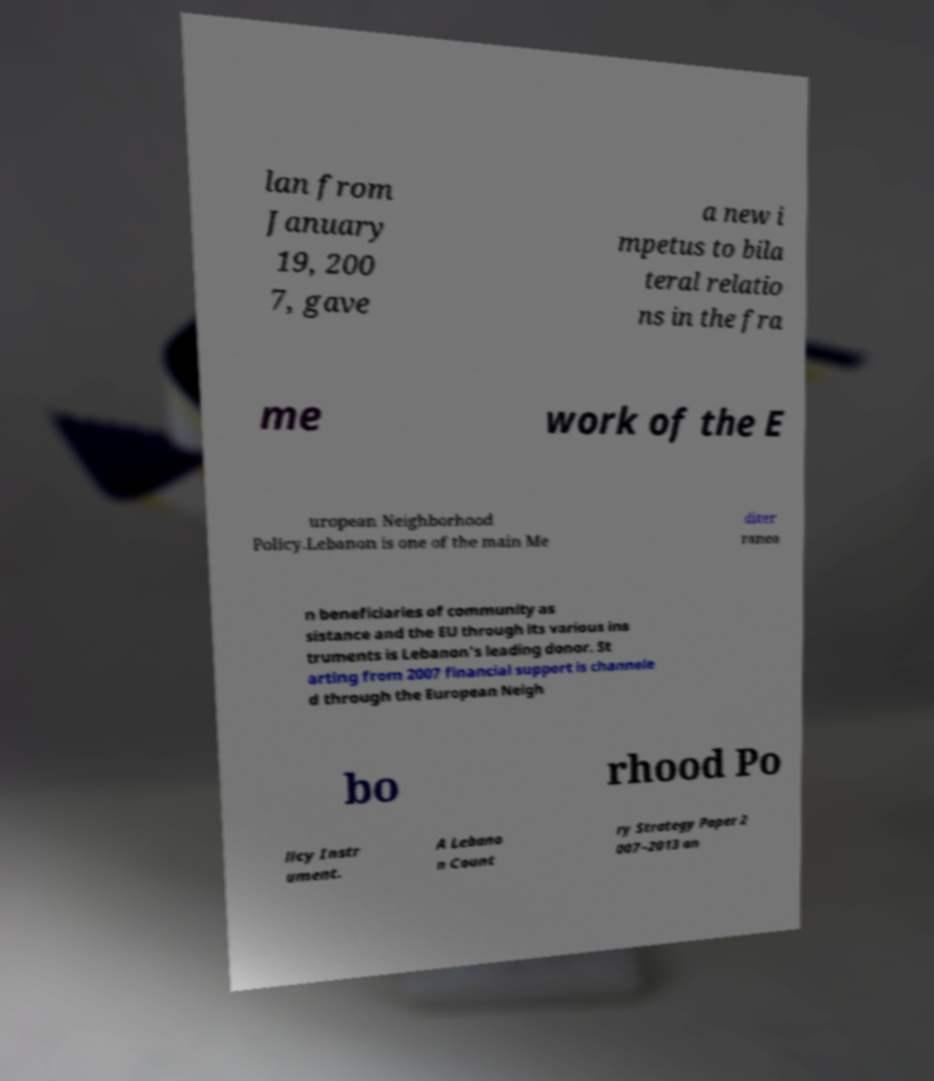I need the written content from this picture converted into text. Can you do that? lan from January 19, 200 7, gave a new i mpetus to bila teral relatio ns in the fra me work of the E uropean Neighborhood Policy.Lebanon is one of the main Me diter ranea n beneficiaries of community as sistance and the EU through its various ins truments is Lebanon's leading donor. St arting from 2007 financial support is channele d through the European Neigh bo rhood Po licy Instr ument. A Lebano n Count ry Strategy Paper 2 007–2013 an 